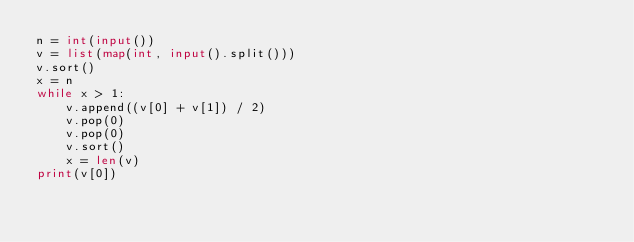<code> <loc_0><loc_0><loc_500><loc_500><_Python_>n = int(input())
v = list(map(int, input().split()))
v.sort()
x = n
while x > 1:
    v.append((v[0] + v[1]) / 2)
    v.pop(0)
    v.pop(0)
    v.sort()
    x = len(v)
print(v[0])</code> 